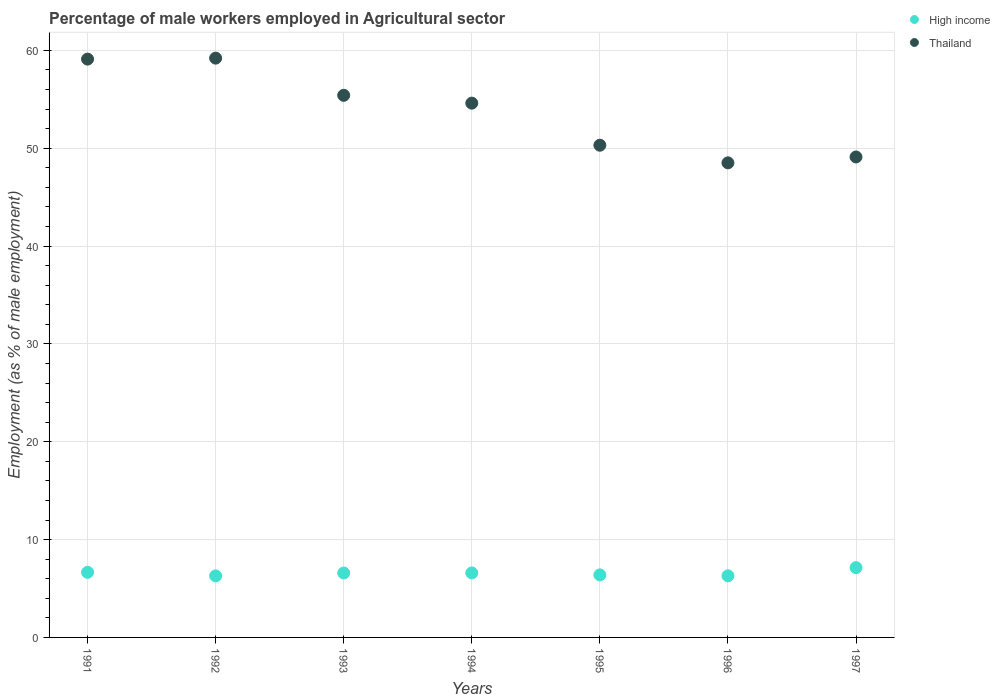What is the percentage of male workers employed in Agricultural sector in Thailand in 1992?
Keep it short and to the point. 59.2. Across all years, what is the maximum percentage of male workers employed in Agricultural sector in High income?
Your response must be concise. 7.13. Across all years, what is the minimum percentage of male workers employed in Agricultural sector in Thailand?
Offer a terse response. 48.5. What is the total percentage of male workers employed in Agricultural sector in Thailand in the graph?
Provide a succinct answer. 376.2. What is the difference between the percentage of male workers employed in Agricultural sector in Thailand in 1993 and that in 1995?
Your response must be concise. 5.1. What is the difference between the percentage of male workers employed in Agricultural sector in High income in 1991 and the percentage of male workers employed in Agricultural sector in Thailand in 1995?
Provide a short and direct response. -43.64. What is the average percentage of male workers employed in Agricultural sector in High income per year?
Ensure brevity in your answer.  6.56. In the year 1993, what is the difference between the percentage of male workers employed in Agricultural sector in High income and percentage of male workers employed in Agricultural sector in Thailand?
Provide a short and direct response. -48.81. In how many years, is the percentage of male workers employed in Agricultural sector in Thailand greater than 52 %?
Provide a succinct answer. 4. What is the ratio of the percentage of male workers employed in Agricultural sector in Thailand in 1991 to that in 1995?
Offer a very short reply. 1.17. Is the percentage of male workers employed in Agricultural sector in Thailand in 1991 less than that in 1994?
Offer a terse response. No. What is the difference between the highest and the second highest percentage of male workers employed in Agricultural sector in High income?
Make the answer very short. 0.48. What is the difference between the highest and the lowest percentage of male workers employed in Agricultural sector in Thailand?
Your answer should be very brief. 10.7. Is the sum of the percentage of male workers employed in Agricultural sector in Thailand in 1993 and 1995 greater than the maximum percentage of male workers employed in Agricultural sector in High income across all years?
Your response must be concise. Yes. How many dotlines are there?
Ensure brevity in your answer.  2. How many years are there in the graph?
Your answer should be very brief. 7. What is the difference between two consecutive major ticks on the Y-axis?
Provide a short and direct response. 10. Does the graph contain any zero values?
Provide a short and direct response. No. Does the graph contain grids?
Make the answer very short. Yes. Where does the legend appear in the graph?
Ensure brevity in your answer.  Top right. What is the title of the graph?
Provide a succinct answer. Percentage of male workers employed in Agricultural sector. Does "Macedonia" appear as one of the legend labels in the graph?
Make the answer very short. No. What is the label or title of the X-axis?
Your answer should be very brief. Years. What is the label or title of the Y-axis?
Keep it short and to the point. Employment (as % of male employment). What is the Employment (as % of male employment) of High income in 1991?
Offer a terse response. 6.66. What is the Employment (as % of male employment) in Thailand in 1991?
Your response must be concise. 59.1. What is the Employment (as % of male employment) in High income in 1992?
Provide a short and direct response. 6.29. What is the Employment (as % of male employment) in Thailand in 1992?
Your response must be concise. 59.2. What is the Employment (as % of male employment) of High income in 1993?
Offer a very short reply. 6.59. What is the Employment (as % of male employment) in Thailand in 1993?
Ensure brevity in your answer.  55.4. What is the Employment (as % of male employment) in High income in 1994?
Offer a terse response. 6.59. What is the Employment (as % of male employment) of Thailand in 1994?
Give a very brief answer. 54.6. What is the Employment (as % of male employment) in High income in 1995?
Offer a terse response. 6.39. What is the Employment (as % of male employment) in Thailand in 1995?
Your answer should be very brief. 50.3. What is the Employment (as % of male employment) of High income in 1996?
Offer a terse response. 6.3. What is the Employment (as % of male employment) of Thailand in 1996?
Provide a short and direct response. 48.5. What is the Employment (as % of male employment) of High income in 1997?
Offer a terse response. 7.13. What is the Employment (as % of male employment) of Thailand in 1997?
Make the answer very short. 49.1. Across all years, what is the maximum Employment (as % of male employment) in High income?
Make the answer very short. 7.13. Across all years, what is the maximum Employment (as % of male employment) in Thailand?
Your answer should be very brief. 59.2. Across all years, what is the minimum Employment (as % of male employment) in High income?
Provide a short and direct response. 6.29. Across all years, what is the minimum Employment (as % of male employment) in Thailand?
Your answer should be very brief. 48.5. What is the total Employment (as % of male employment) in High income in the graph?
Offer a very short reply. 45.95. What is the total Employment (as % of male employment) of Thailand in the graph?
Keep it short and to the point. 376.2. What is the difference between the Employment (as % of male employment) in High income in 1991 and that in 1992?
Offer a terse response. 0.37. What is the difference between the Employment (as % of male employment) in Thailand in 1991 and that in 1992?
Give a very brief answer. -0.1. What is the difference between the Employment (as % of male employment) in High income in 1991 and that in 1993?
Give a very brief answer. 0.07. What is the difference between the Employment (as % of male employment) in High income in 1991 and that in 1994?
Make the answer very short. 0.06. What is the difference between the Employment (as % of male employment) of Thailand in 1991 and that in 1994?
Give a very brief answer. 4.5. What is the difference between the Employment (as % of male employment) in High income in 1991 and that in 1995?
Ensure brevity in your answer.  0.27. What is the difference between the Employment (as % of male employment) of High income in 1991 and that in 1996?
Give a very brief answer. 0.36. What is the difference between the Employment (as % of male employment) of High income in 1991 and that in 1997?
Provide a short and direct response. -0.48. What is the difference between the Employment (as % of male employment) of High income in 1992 and that in 1993?
Your response must be concise. -0.3. What is the difference between the Employment (as % of male employment) in Thailand in 1992 and that in 1993?
Your answer should be compact. 3.8. What is the difference between the Employment (as % of male employment) of High income in 1992 and that in 1994?
Your response must be concise. -0.3. What is the difference between the Employment (as % of male employment) in High income in 1992 and that in 1995?
Your answer should be compact. -0.1. What is the difference between the Employment (as % of male employment) of High income in 1992 and that in 1996?
Provide a short and direct response. -0.01. What is the difference between the Employment (as % of male employment) in High income in 1992 and that in 1997?
Ensure brevity in your answer.  -0.84. What is the difference between the Employment (as % of male employment) in Thailand in 1992 and that in 1997?
Keep it short and to the point. 10.1. What is the difference between the Employment (as % of male employment) in High income in 1993 and that in 1994?
Offer a very short reply. -0.01. What is the difference between the Employment (as % of male employment) of Thailand in 1993 and that in 1994?
Make the answer very short. 0.8. What is the difference between the Employment (as % of male employment) in High income in 1993 and that in 1995?
Provide a succinct answer. 0.19. What is the difference between the Employment (as % of male employment) of High income in 1993 and that in 1996?
Keep it short and to the point. 0.29. What is the difference between the Employment (as % of male employment) in High income in 1993 and that in 1997?
Offer a very short reply. -0.55. What is the difference between the Employment (as % of male employment) of Thailand in 1993 and that in 1997?
Provide a short and direct response. 6.3. What is the difference between the Employment (as % of male employment) of High income in 1994 and that in 1995?
Offer a very short reply. 0.2. What is the difference between the Employment (as % of male employment) in High income in 1994 and that in 1996?
Offer a very short reply. 0.3. What is the difference between the Employment (as % of male employment) in Thailand in 1994 and that in 1996?
Your answer should be compact. 6.1. What is the difference between the Employment (as % of male employment) of High income in 1994 and that in 1997?
Provide a short and direct response. -0.54. What is the difference between the Employment (as % of male employment) of Thailand in 1994 and that in 1997?
Make the answer very short. 5.5. What is the difference between the Employment (as % of male employment) in High income in 1995 and that in 1996?
Give a very brief answer. 0.09. What is the difference between the Employment (as % of male employment) in High income in 1995 and that in 1997?
Keep it short and to the point. -0.74. What is the difference between the Employment (as % of male employment) in High income in 1996 and that in 1997?
Provide a succinct answer. -0.84. What is the difference between the Employment (as % of male employment) of High income in 1991 and the Employment (as % of male employment) of Thailand in 1992?
Your answer should be compact. -52.54. What is the difference between the Employment (as % of male employment) of High income in 1991 and the Employment (as % of male employment) of Thailand in 1993?
Give a very brief answer. -48.74. What is the difference between the Employment (as % of male employment) in High income in 1991 and the Employment (as % of male employment) in Thailand in 1994?
Give a very brief answer. -47.94. What is the difference between the Employment (as % of male employment) of High income in 1991 and the Employment (as % of male employment) of Thailand in 1995?
Provide a short and direct response. -43.64. What is the difference between the Employment (as % of male employment) in High income in 1991 and the Employment (as % of male employment) in Thailand in 1996?
Your answer should be compact. -41.84. What is the difference between the Employment (as % of male employment) of High income in 1991 and the Employment (as % of male employment) of Thailand in 1997?
Make the answer very short. -42.44. What is the difference between the Employment (as % of male employment) of High income in 1992 and the Employment (as % of male employment) of Thailand in 1993?
Offer a very short reply. -49.11. What is the difference between the Employment (as % of male employment) in High income in 1992 and the Employment (as % of male employment) in Thailand in 1994?
Make the answer very short. -48.31. What is the difference between the Employment (as % of male employment) in High income in 1992 and the Employment (as % of male employment) in Thailand in 1995?
Provide a succinct answer. -44.01. What is the difference between the Employment (as % of male employment) of High income in 1992 and the Employment (as % of male employment) of Thailand in 1996?
Provide a succinct answer. -42.21. What is the difference between the Employment (as % of male employment) of High income in 1992 and the Employment (as % of male employment) of Thailand in 1997?
Make the answer very short. -42.81. What is the difference between the Employment (as % of male employment) of High income in 1993 and the Employment (as % of male employment) of Thailand in 1994?
Offer a very short reply. -48.01. What is the difference between the Employment (as % of male employment) of High income in 1993 and the Employment (as % of male employment) of Thailand in 1995?
Ensure brevity in your answer.  -43.71. What is the difference between the Employment (as % of male employment) in High income in 1993 and the Employment (as % of male employment) in Thailand in 1996?
Offer a terse response. -41.91. What is the difference between the Employment (as % of male employment) in High income in 1993 and the Employment (as % of male employment) in Thailand in 1997?
Provide a succinct answer. -42.51. What is the difference between the Employment (as % of male employment) of High income in 1994 and the Employment (as % of male employment) of Thailand in 1995?
Keep it short and to the point. -43.71. What is the difference between the Employment (as % of male employment) in High income in 1994 and the Employment (as % of male employment) in Thailand in 1996?
Keep it short and to the point. -41.91. What is the difference between the Employment (as % of male employment) in High income in 1994 and the Employment (as % of male employment) in Thailand in 1997?
Make the answer very short. -42.51. What is the difference between the Employment (as % of male employment) of High income in 1995 and the Employment (as % of male employment) of Thailand in 1996?
Offer a very short reply. -42.11. What is the difference between the Employment (as % of male employment) in High income in 1995 and the Employment (as % of male employment) in Thailand in 1997?
Your response must be concise. -42.71. What is the difference between the Employment (as % of male employment) of High income in 1996 and the Employment (as % of male employment) of Thailand in 1997?
Ensure brevity in your answer.  -42.8. What is the average Employment (as % of male employment) of High income per year?
Offer a terse response. 6.56. What is the average Employment (as % of male employment) in Thailand per year?
Your answer should be very brief. 53.74. In the year 1991, what is the difference between the Employment (as % of male employment) of High income and Employment (as % of male employment) of Thailand?
Your response must be concise. -52.44. In the year 1992, what is the difference between the Employment (as % of male employment) of High income and Employment (as % of male employment) of Thailand?
Make the answer very short. -52.91. In the year 1993, what is the difference between the Employment (as % of male employment) in High income and Employment (as % of male employment) in Thailand?
Make the answer very short. -48.81. In the year 1994, what is the difference between the Employment (as % of male employment) in High income and Employment (as % of male employment) in Thailand?
Provide a short and direct response. -48.01. In the year 1995, what is the difference between the Employment (as % of male employment) of High income and Employment (as % of male employment) of Thailand?
Your answer should be very brief. -43.91. In the year 1996, what is the difference between the Employment (as % of male employment) in High income and Employment (as % of male employment) in Thailand?
Provide a short and direct response. -42.2. In the year 1997, what is the difference between the Employment (as % of male employment) of High income and Employment (as % of male employment) of Thailand?
Your answer should be compact. -41.97. What is the ratio of the Employment (as % of male employment) in High income in 1991 to that in 1992?
Offer a terse response. 1.06. What is the ratio of the Employment (as % of male employment) of Thailand in 1991 to that in 1992?
Make the answer very short. 1. What is the ratio of the Employment (as % of male employment) of High income in 1991 to that in 1993?
Ensure brevity in your answer.  1.01. What is the ratio of the Employment (as % of male employment) in Thailand in 1991 to that in 1993?
Offer a very short reply. 1.07. What is the ratio of the Employment (as % of male employment) of High income in 1991 to that in 1994?
Offer a terse response. 1.01. What is the ratio of the Employment (as % of male employment) of Thailand in 1991 to that in 1994?
Your answer should be compact. 1.08. What is the ratio of the Employment (as % of male employment) of High income in 1991 to that in 1995?
Keep it short and to the point. 1.04. What is the ratio of the Employment (as % of male employment) of Thailand in 1991 to that in 1995?
Ensure brevity in your answer.  1.18. What is the ratio of the Employment (as % of male employment) in High income in 1991 to that in 1996?
Offer a very short reply. 1.06. What is the ratio of the Employment (as % of male employment) in Thailand in 1991 to that in 1996?
Provide a succinct answer. 1.22. What is the ratio of the Employment (as % of male employment) of High income in 1991 to that in 1997?
Provide a short and direct response. 0.93. What is the ratio of the Employment (as % of male employment) of Thailand in 1991 to that in 1997?
Your answer should be very brief. 1.2. What is the ratio of the Employment (as % of male employment) in High income in 1992 to that in 1993?
Keep it short and to the point. 0.95. What is the ratio of the Employment (as % of male employment) in Thailand in 1992 to that in 1993?
Ensure brevity in your answer.  1.07. What is the ratio of the Employment (as % of male employment) of High income in 1992 to that in 1994?
Offer a terse response. 0.95. What is the ratio of the Employment (as % of male employment) of Thailand in 1992 to that in 1994?
Your answer should be very brief. 1.08. What is the ratio of the Employment (as % of male employment) of High income in 1992 to that in 1995?
Your response must be concise. 0.98. What is the ratio of the Employment (as % of male employment) in Thailand in 1992 to that in 1995?
Your response must be concise. 1.18. What is the ratio of the Employment (as % of male employment) of High income in 1992 to that in 1996?
Your answer should be compact. 1. What is the ratio of the Employment (as % of male employment) of Thailand in 1992 to that in 1996?
Offer a terse response. 1.22. What is the ratio of the Employment (as % of male employment) of High income in 1992 to that in 1997?
Give a very brief answer. 0.88. What is the ratio of the Employment (as % of male employment) in Thailand in 1992 to that in 1997?
Offer a terse response. 1.21. What is the ratio of the Employment (as % of male employment) of High income in 1993 to that in 1994?
Your answer should be compact. 1. What is the ratio of the Employment (as % of male employment) of Thailand in 1993 to that in 1994?
Offer a terse response. 1.01. What is the ratio of the Employment (as % of male employment) of High income in 1993 to that in 1995?
Make the answer very short. 1.03. What is the ratio of the Employment (as % of male employment) of Thailand in 1993 to that in 1995?
Give a very brief answer. 1.1. What is the ratio of the Employment (as % of male employment) of High income in 1993 to that in 1996?
Ensure brevity in your answer.  1.05. What is the ratio of the Employment (as % of male employment) in Thailand in 1993 to that in 1996?
Offer a very short reply. 1.14. What is the ratio of the Employment (as % of male employment) of High income in 1993 to that in 1997?
Offer a very short reply. 0.92. What is the ratio of the Employment (as % of male employment) of Thailand in 1993 to that in 1997?
Keep it short and to the point. 1.13. What is the ratio of the Employment (as % of male employment) of High income in 1994 to that in 1995?
Offer a very short reply. 1.03. What is the ratio of the Employment (as % of male employment) in Thailand in 1994 to that in 1995?
Offer a terse response. 1.09. What is the ratio of the Employment (as % of male employment) in High income in 1994 to that in 1996?
Give a very brief answer. 1.05. What is the ratio of the Employment (as % of male employment) of Thailand in 1994 to that in 1996?
Offer a terse response. 1.13. What is the ratio of the Employment (as % of male employment) in High income in 1994 to that in 1997?
Ensure brevity in your answer.  0.92. What is the ratio of the Employment (as % of male employment) in Thailand in 1994 to that in 1997?
Provide a short and direct response. 1.11. What is the ratio of the Employment (as % of male employment) of High income in 1995 to that in 1996?
Make the answer very short. 1.01. What is the ratio of the Employment (as % of male employment) in Thailand in 1995 to that in 1996?
Provide a short and direct response. 1.04. What is the ratio of the Employment (as % of male employment) in High income in 1995 to that in 1997?
Ensure brevity in your answer.  0.9. What is the ratio of the Employment (as % of male employment) of Thailand in 1995 to that in 1997?
Provide a short and direct response. 1.02. What is the ratio of the Employment (as % of male employment) in High income in 1996 to that in 1997?
Keep it short and to the point. 0.88. What is the difference between the highest and the second highest Employment (as % of male employment) in High income?
Provide a succinct answer. 0.48. What is the difference between the highest and the second highest Employment (as % of male employment) of Thailand?
Provide a short and direct response. 0.1. What is the difference between the highest and the lowest Employment (as % of male employment) in High income?
Provide a succinct answer. 0.84. 